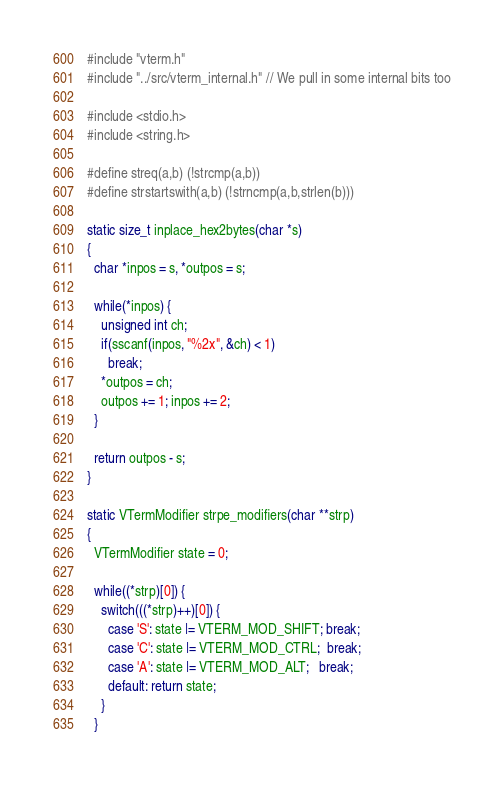Convert code to text. <code><loc_0><loc_0><loc_500><loc_500><_C_>#include "vterm.h"
#include "../src/vterm_internal.h" // We pull in some internal bits too

#include <stdio.h>
#include <string.h>

#define streq(a,b) (!strcmp(a,b))
#define strstartswith(a,b) (!strncmp(a,b,strlen(b)))

static size_t inplace_hex2bytes(char *s)
{
  char *inpos = s, *outpos = s;

  while(*inpos) {
    unsigned int ch;
    if(sscanf(inpos, "%2x", &ch) < 1)
      break;
    *outpos = ch;
    outpos += 1; inpos += 2;
  }

  return outpos - s;
}

static VTermModifier strpe_modifiers(char **strp)
{
  VTermModifier state = 0;

  while((*strp)[0]) {
    switch(((*strp)++)[0]) {
      case 'S': state |= VTERM_MOD_SHIFT; break;
      case 'C': state |= VTERM_MOD_CTRL;  break;
      case 'A': state |= VTERM_MOD_ALT;   break;
      default: return state;
    }
  }
</code> 